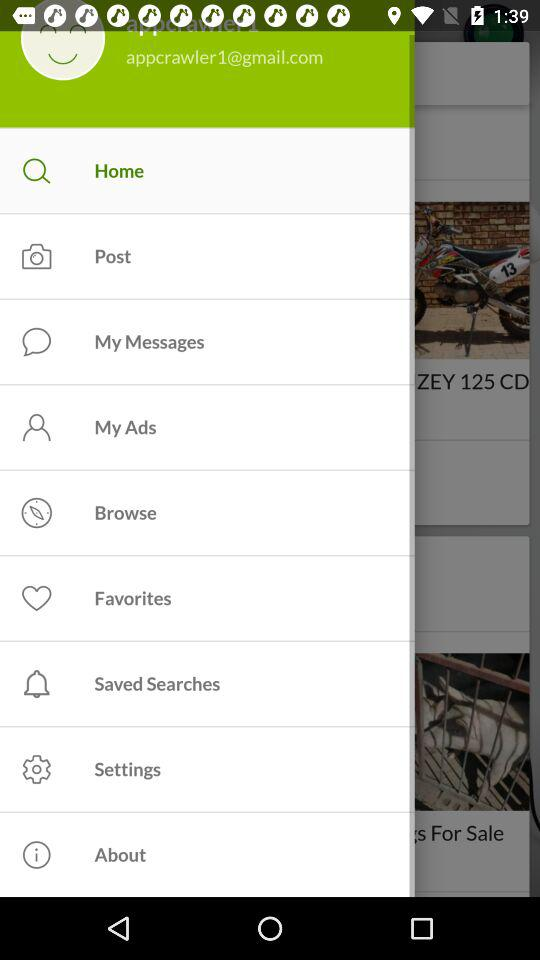What is the user's email ID? The user's email ID is appcrawler1@gmail.com. 